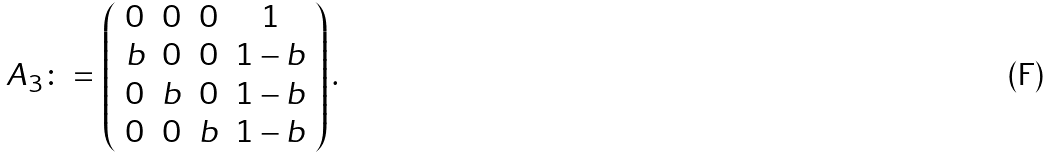Convert formula to latex. <formula><loc_0><loc_0><loc_500><loc_500>A _ { 3 } \colon = \left ( \begin{array} { c c c c } 0 & 0 & 0 & 1 \\ b & 0 & 0 & 1 - b \\ 0 & b & 0 & 1 - b \\ 0 & 0 & b & 1 - b \\ \end{array} \right ) .</formula> 